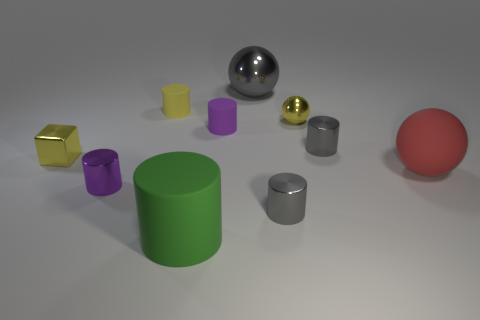Subtract 3 cylinders. How many cylinders are left? 3 Subtract all gray metal cylinders. How many cylinders are left? 4 Subtract all green cylinders. How many cylinders are left? 5 Subtract all green cylinders. Subtract all cyan cubes. How many cylinders are left? 5 Subtract all cylinders. How many objects are left? 4 Subtract all large gray shiny objects. Subtract all gray shiny objects. How many objects are left? 6 Add 1 large balls. How many large balls are left? 3 Add 4 tiny metallic cylinders. How many tiny metallic cylinders exist? 7 Subtract 1 yellow blocks. How many objects are left? 9 